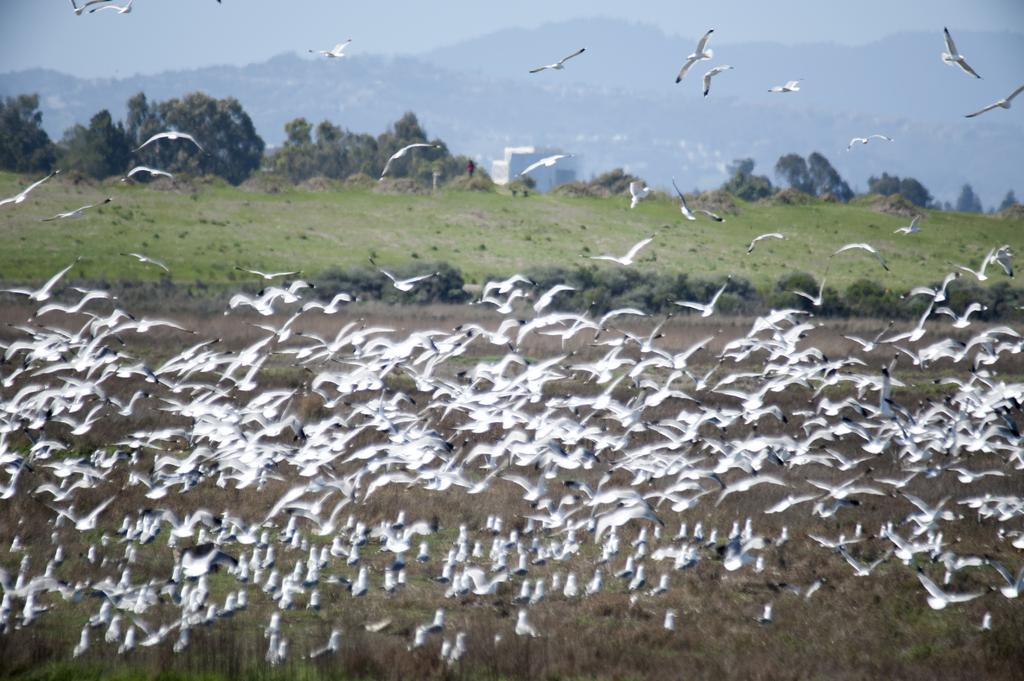What is the main subject of the image? The main subject of the image is a group of birds. What are the birds doing in the image? The birds are flying in the air. What can be seen in the background of the image? There are trees, grass, hills, and the sky visible in the background of the image. What is the rate at which the button is being pressed in the image? There is no button present in the image, so it is not possible to determine the rate at which it is being pressed. 